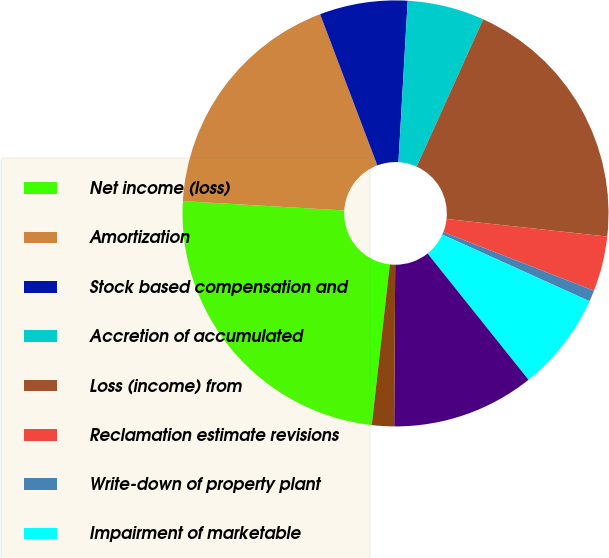Convert chart to OTSL. <chart><loc_0><loc_0><loc_500><loc_500><pie_chart><fcel>Net income (loss)<fcel>Amortization<fcel>Stock based compensation and<fcel>Accretion of accumulated<fcel>Loss (income) from<fcel>Reclamation estimate revisions<fcel>Write-down of property plant<fcel>Impairment of marketable<fcel>Deferred income taxes<fcel>Gain on asset sales net<nl><fcel>24.14%<fcel>18.32%<fcel>6.67%<fcel>5.84%<fcel>19.98%<fcel>4.18%<fcel>0.85%<fcel>7.5%<fcel>10.83%<fcel>1.68%<nl></chart> 